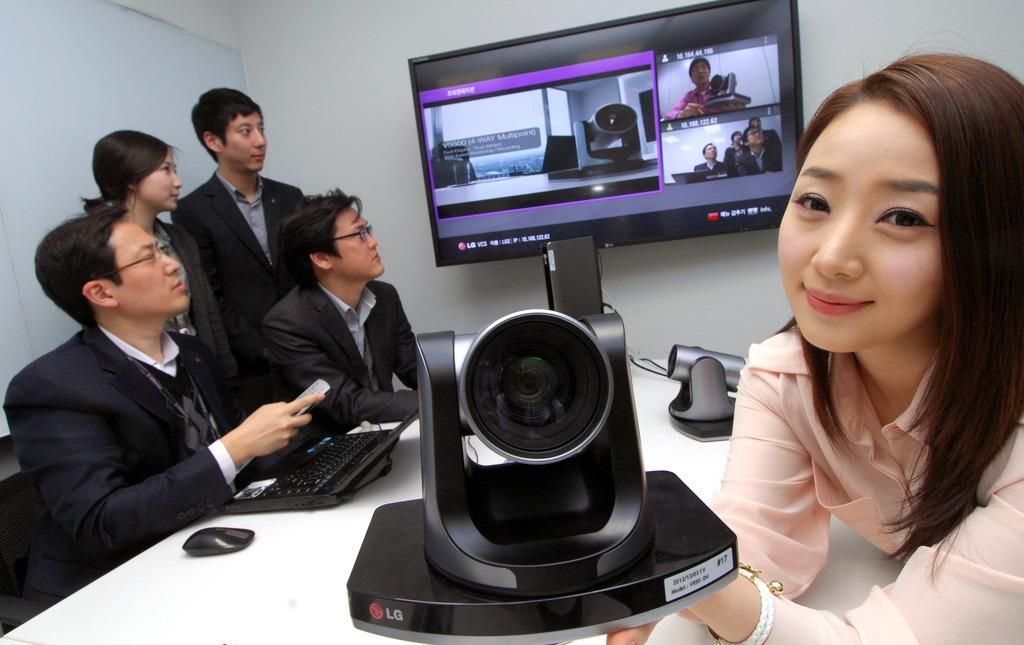How many people are present in the image? There are five persons in the image. What is the woman on the right side doing? The woman on the right side is holding an object in her hand. What are the people on the left side focused on? The people on the left side are looking at a screen. Can you tell me how deep the lake is in the image? There is no lake present in the image. What fact is being discussed by the people on the left side? The image does not provide information about any specific fact being discussed by the people on the left side. 